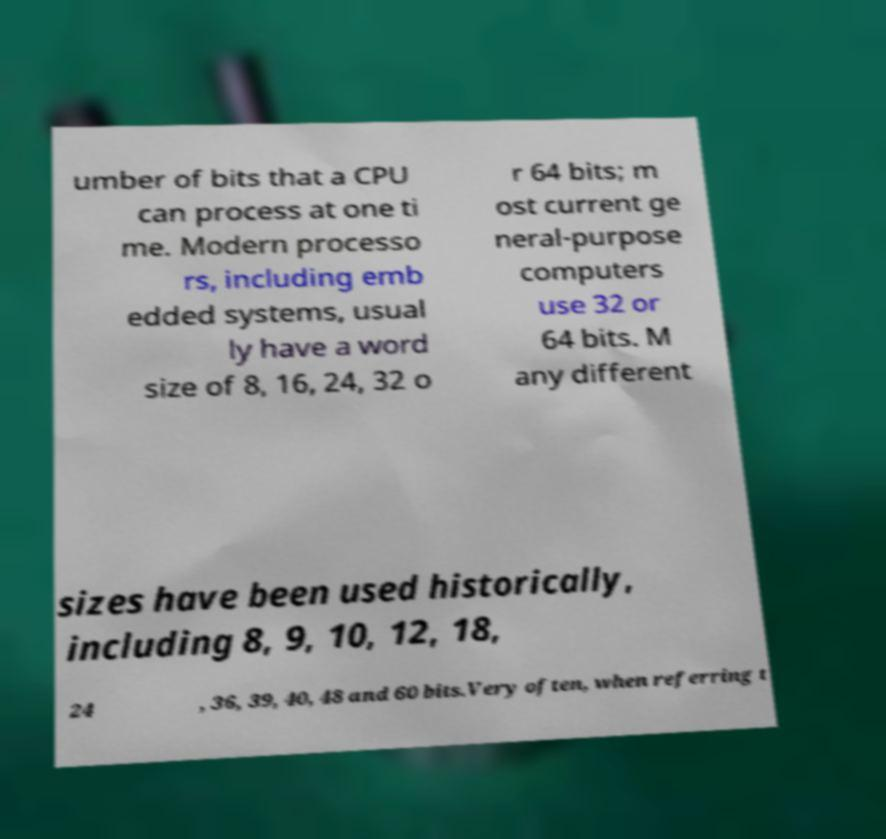Could you extract and type out the text from this image? umber of bits that a CPU can process at one ti me. Modern processo rs, including emb edded systems, usual ly have a word size of 8, 16, 24, 32 o r 64 bits; m ost current ge neral-purpose computers use 32 or 64 bits. M any different sizes have been used historically, including 8, 9, 10, 12, 18, 24 , 36, 39, 40, 48 and 60 bits.Very often, when referring t 